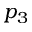<formula> <loc_0><loc_0><loc_500><loc_500>p _ { 3 }</formula> 